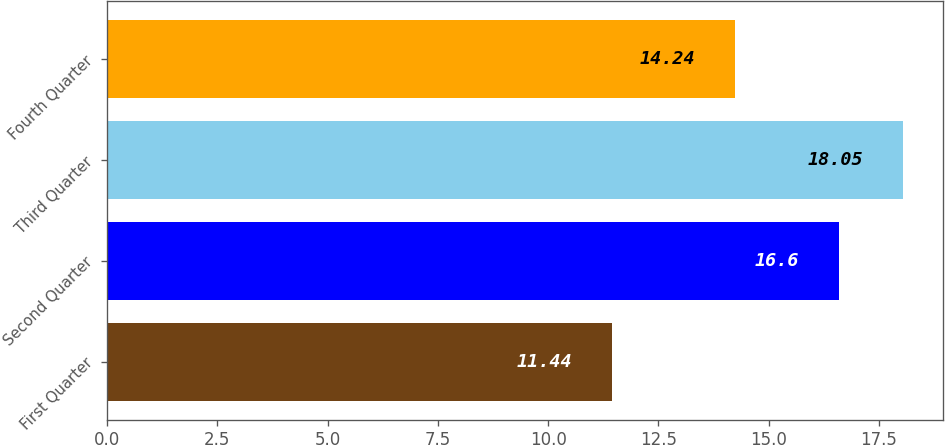<chart> <loc_0><loc_0><loc_500><loc_500><bar_chart><fcel>First Quarter<fcel>Second Quarter<fcel>Third Quarter<fcel>Fourth Quarter<nl><fcel>11.44<fcel>16.6<fcel>18.05<fcel>14.24<nl></chart> 